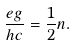Convert formula to latex. <formula><loc_0><loc_0><loc_500><loc_500>\frac { e g } { h c } = \frac { 1 } { 2 } n .</formula> 